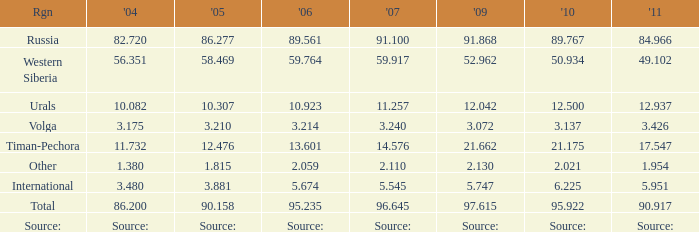What is the 2010 Lukoil oil prodroduction when in 2009 oil production 21.662 million tonnes? 21.175. 